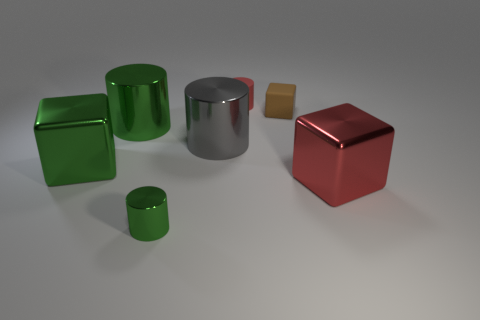Subtract all gray cubes. How many green cylinders are left? 2 Subtract all metallic cubes. How many cubes are left? 1 Subtract all gray cylinders. How many cylinders are left? 3 Add 1 green blocks. How many objects exist? 8 Subtract all brown cylinders. Subtract all purple spheres. How many cylinders are left? 4 Subtract all blocks. How many objects are left? 4 Add 6 green things. How many green things exist? 9 Subtract 0 yellow cylinders. How many objects are left? 7 Subtract all small metal cylinders. Subtract all blue cylinders. How many objects are left? 6 Add 3 brown cubes. How many brown cubes are left? 4 